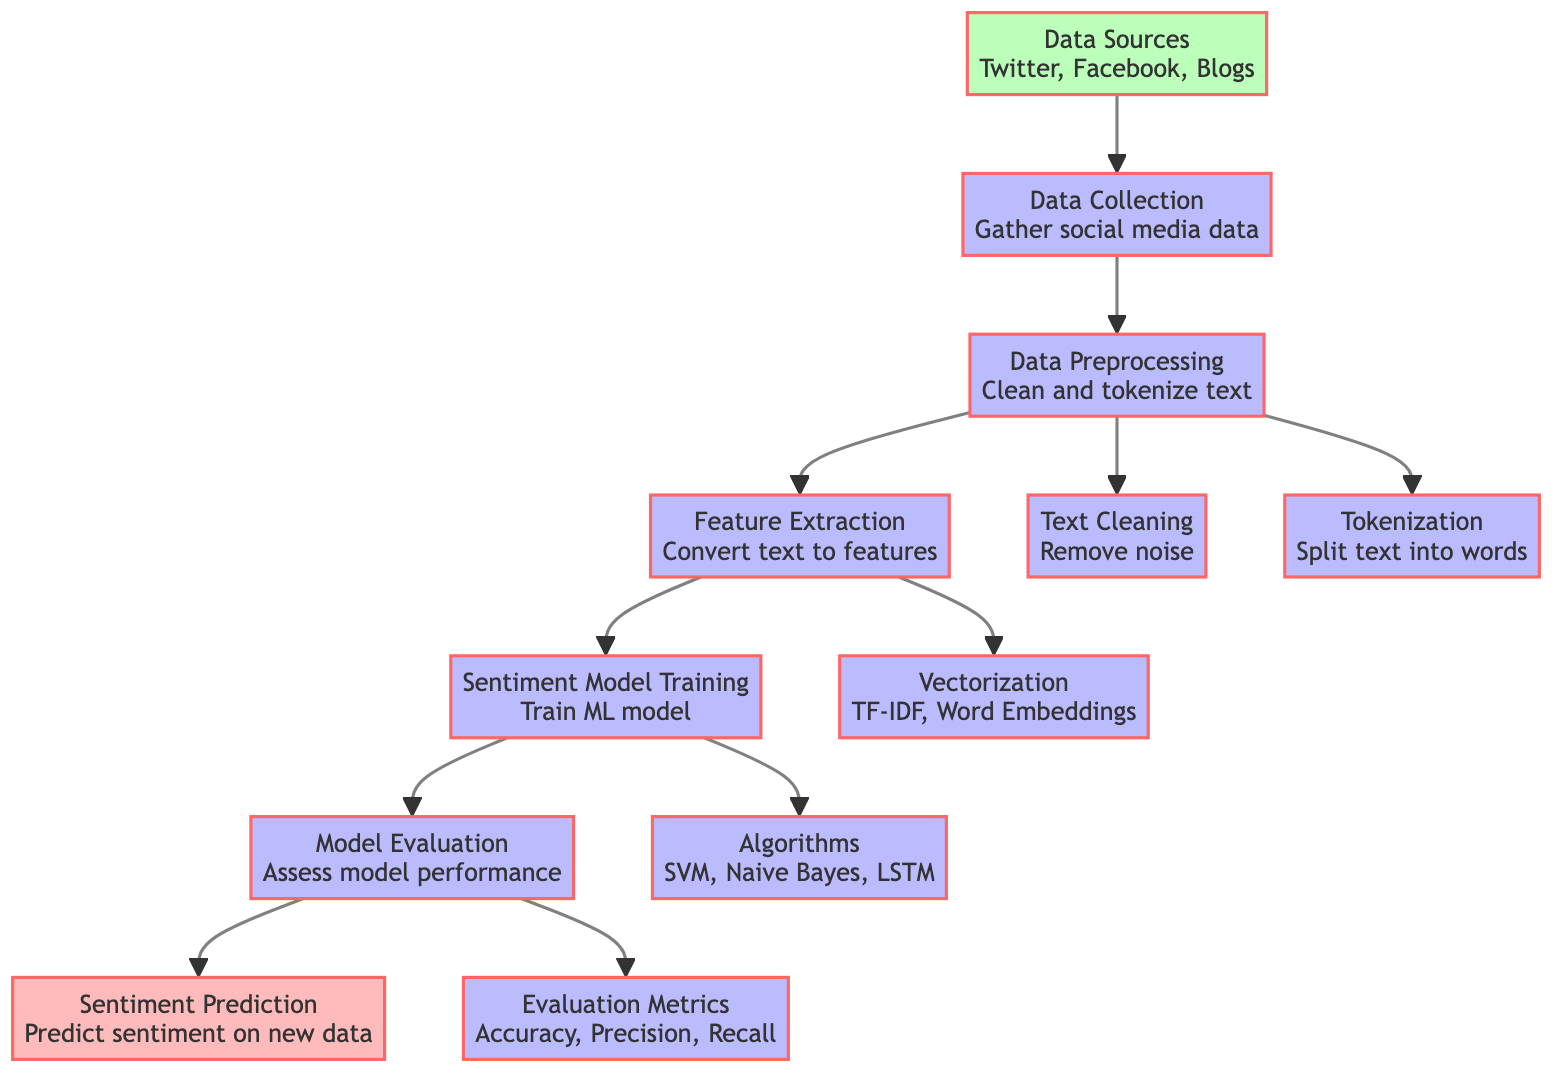What are the data sources mentioned? The diagram lists three data sources for sentiment analysis: Twitter, Facebook, and Blogs. These can be found in the first node labeled "Data Sources."
Answer: Twitter, Facebook, Blogs What is the first step in the process? The first step after collecting data is labeled in the diagram as "Data Collection," which involves gathering social media data. This node connects directly from the "Data Sources" node.
Answer: Data Collection How many preprocessing steps are there? The diagram shows two distinct preprocessing steps: "Text Cleaning" and "Tokenization," both stemming from the "Data Collection" node, making a total of two.
Answer: 2 What is used for feature extraction? The feature extraction process involves converting the text to features, which is represented in the diagram's "Feature Extraction" node. The methods include TF-IDF and Word Embeddings as indicated in the connected node.
Answer: TF-IDF, Word Embeddings Which algorithms are mentioned for model training? The diagram specifies three algorithms for sentiment model training: SVM, Naive Bayes, and LSTM, all listed in the "Algorithms" node under "Sentiment Model Training."
Answer: SVM, Naive Bayes, LSTM What metrics are used for model evaluation? The evaluation metrics described in the diagram consist of Accuracy, Precision, and Recall, shown in the "Evaluation Metrics" node connected to the "Model Evaluation" step.
Answer: Accuracy, Precision, Recall Which node connects "Data Collection" and "Feature Extraction"? The "Data Preprocessing" node serves as the connection between "Data Collection" and "Feature Extraction," indicating the workflow sequence from raw data to processed features.
Answer: Data Preprocessing What is the final output of this sentiment analysis process? The final output of the entire process, as indicated in the last node, is "Sentiment Prediction," which deals with predicting sentiment on new data.
Answer: Sentiment Prediction Which steps involve text manipulation? The steps that involve text manipulation in the diagram are "Text Cleaning" and "Tokenization," both stemming from the "Data Collection" node, focusing on preparing the text data for analysis.
Answer: Text Cleaning, Tokenization 